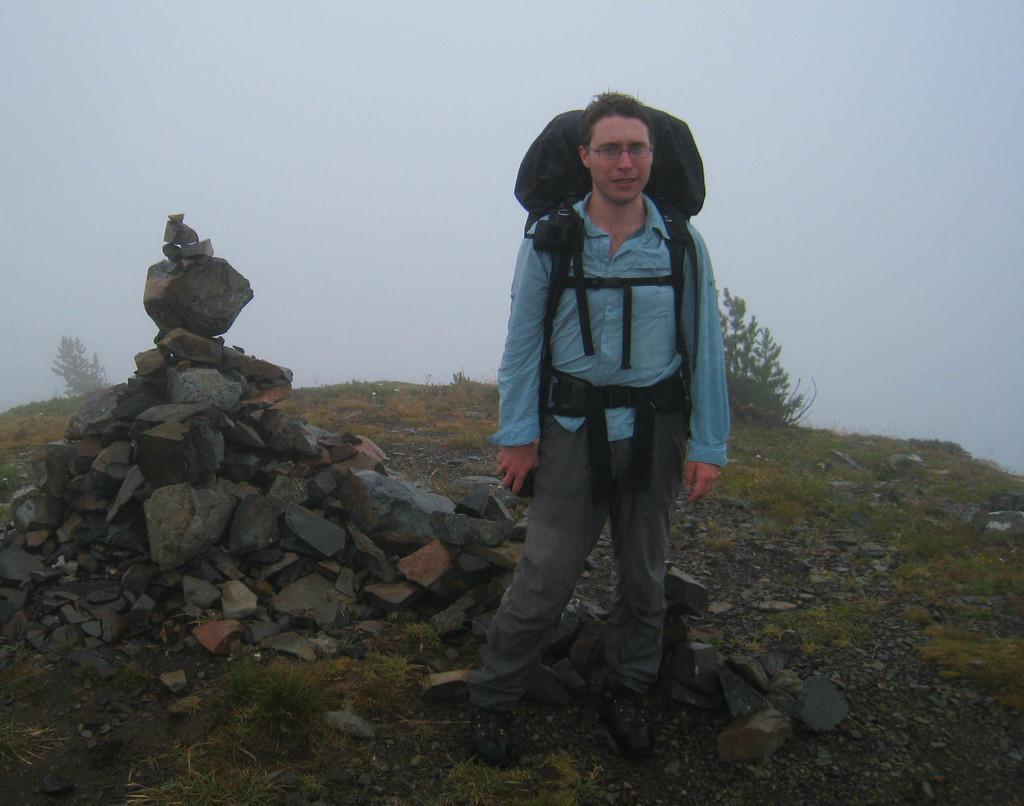Can you describe this image briefly? In the foreground of the picture there is a person wearing a backpack. On the left there are stones. In the center of the picture there are plants and grass. in the background it is foggy. 